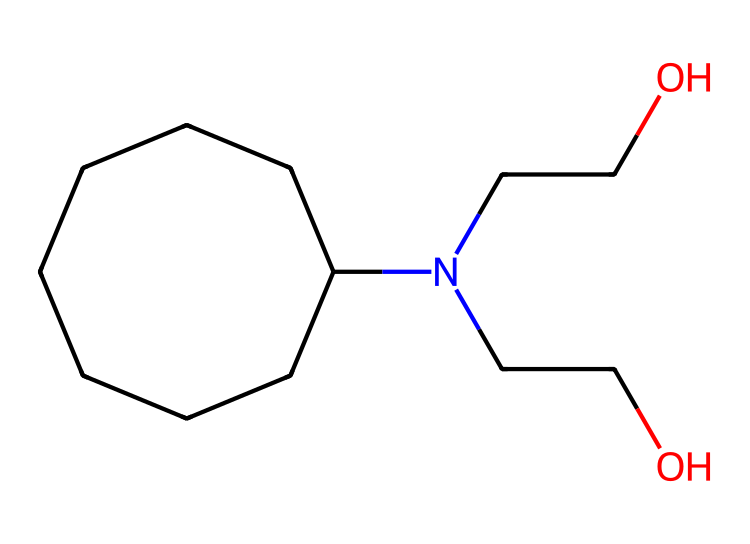What is the core structure of this compound? The compound features a cycloalkane structure, which is primarily a ring composed of carbon atoms. Counting the carbon atoms in the ring, there are eight, making it cyclooctane.
Answer: cyclooctane How many carbon atoms are in this compound? By examining the structure, it can be observed that there are eight carbon atoms in the cycloalkane ring and two additional carbon atoms in the side chains, totaling ten carbon atoms.
Answer: ten What functional groups are present in this compound? The compound contains two hydroxyl (−OH) groups attached to nitrogen, indicating the presence of alcohol functional groups.
Answer: alcohols What is the role of nitrogen in this compound? The nitrogen atom connects the hydrophilic side chains (containing –OH) to the cycloalkane structure, aiding in creating anti-static properties.
Answer: connectivity for anti-static properties How does this compound contribute to anti-static coatings? The hydroxyl groups enhance the ability of the compound to attract moisture, which helps dissipate static charges on computer hardware surfaces.
Answer: moisture attraction for charge dissipation Is this compound saturated or unsaturated? The structure consists only of single bonds between carbon atoms in the ring and does not have any double or triple bonds, indicating it is saturated.
Answer: saturated 